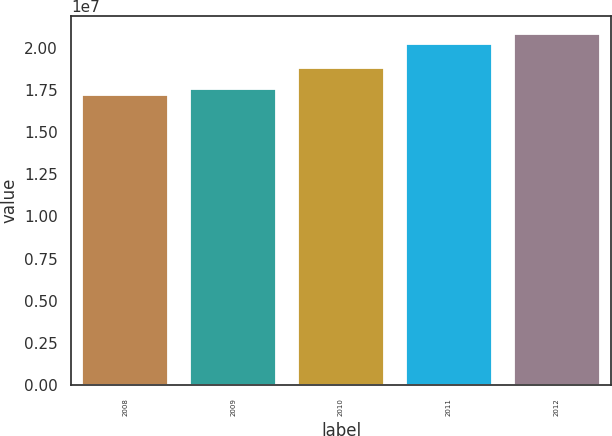Convert chart. <chart><loc_0><loc_0><loc_500><loc_500><bar_chart><fcel>2008<fcel>2009<fcel>2010<fcel>2011<fcel>2012<nl><fcel>1.7184e+07<fcel>1.75479e+07<fcel>1.88e+07<fcel>2.0227e+07<fcel>2.0823e+07<nl></chart> 